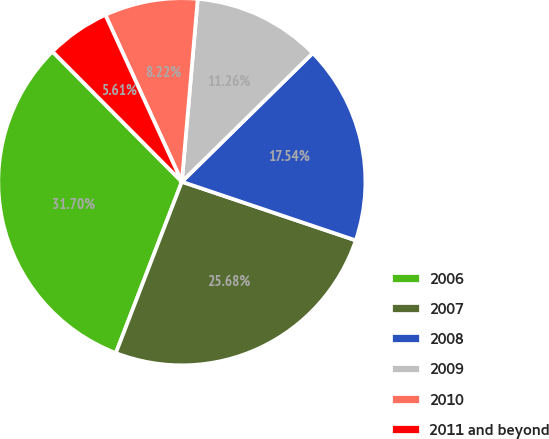Convert chart. <chart><loc_0><loc_0><loc_500><loc_500><pie_chart><fcel>2006<fcel>2007<fcel>2008<fcel>2009<fcel>2010<fcel>2011 and beyond<nl><fcel>31.7%<fcel>25.68%<fcel>17.54%<fcel>11.26%<fcel>8.22%<fcel>5.61%<nl></chart> 